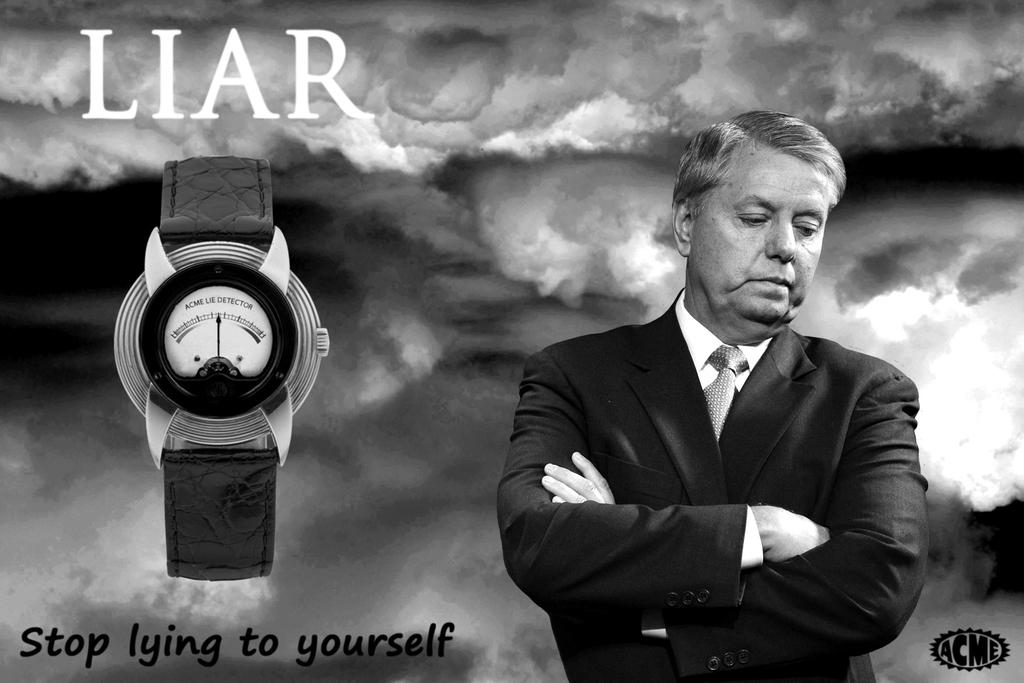Who is present in the image? There is a man in the image. What is the man wearing? The man is wearing a blazer and a tie. What object is located beside the man? There is a watch beside the man. What can be seen in the background of the image? There are clouds in the background of the image. Is there any text visible in the image? Yes, there is some text visible in the image. What type of song is being played at the party in the image? There is no party or song present in the image; it features a man wearing a blazer and tie with a watch beside him and some text visible. What is the ground like in the image? The ground is not visible in the image, as it only shows a man, a watch, and some text against a background of clouds. 